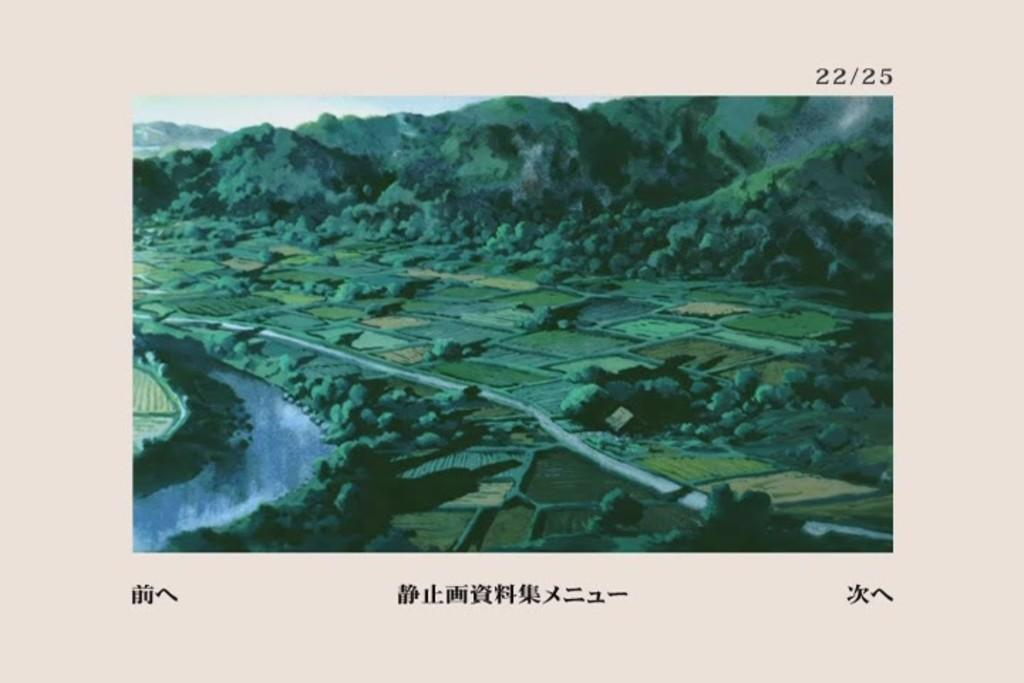What can be seen at the bottom of the image? The ground is visible in the image. What is located on the left side of the image? There is water on the left side of the image. What type of natural feature can be seen in the background of the image? There are mountains in the background of the image. What else is visible in the background of the image? The sky is visible in the background of the image. How many dogs are swimming in the water on the left side of the image? There are no dogs present in the image; it features water on the left side. What type of order is being followed by the mountains in the background? The mountains in the background are not following any specific order, as they are a natural formation. 